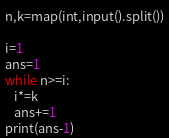<code> <loc_0><loc_0><loc_500><loc_500><_Python_>n,k=map(int,input().split())

i=1
ans=1
while n>=i:
   i*=k
   ans+=1
print(ans-1)</code> 